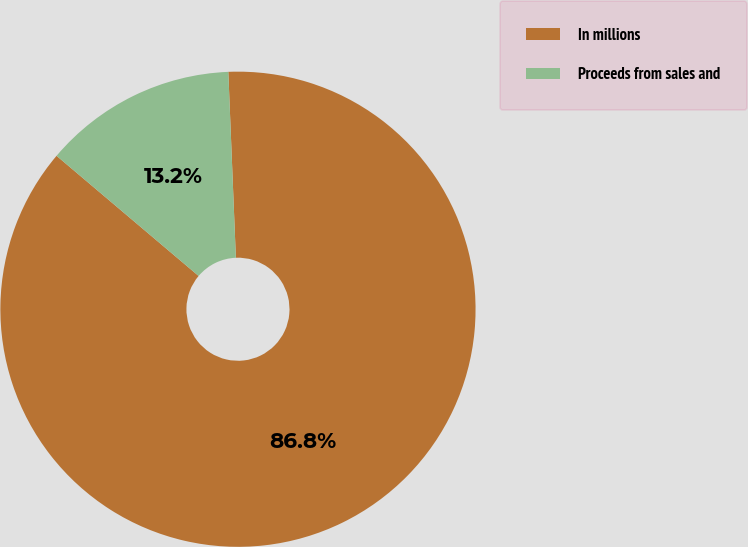Convert chart. <chart><loc_0><loc_0><loc_500><loc_500><pie_chart><fcel>In millions<fcel>Proceeds from sales and<nl><fcel>86.82%<fcel>13.18%<nl></chart> 